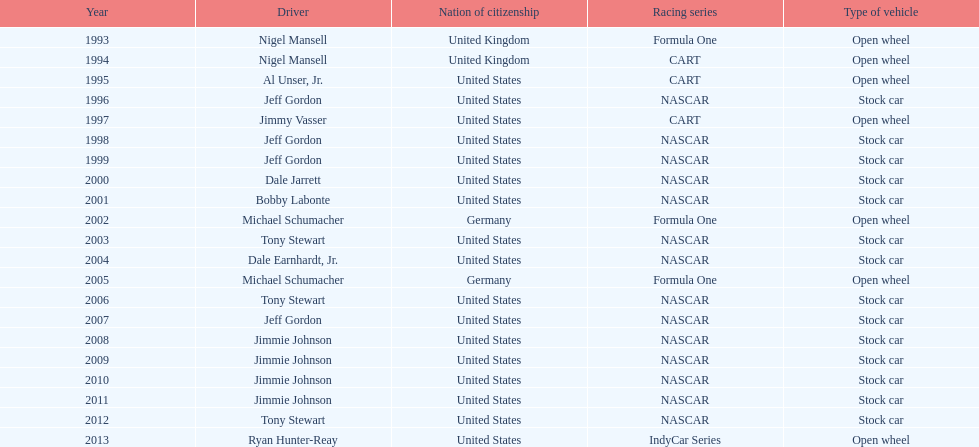Does the united states have more nation of citzenship then united kingdom? Yes. 